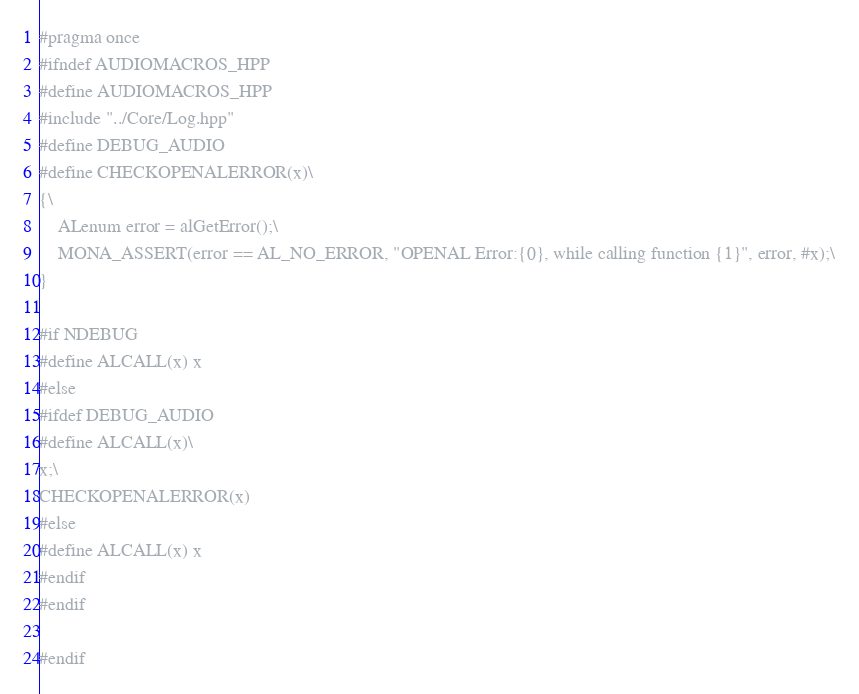Convert code to text. <code><loc_0><loc_0><loc_500><loc_500><_C++_>#pragma once
#ifndef AUDIOMACROS_HPP
#define AUDIOMACROS_HPP
#include "../Core/Log.hpp"
#define DEBUG_AUDIO
#define CHECKOPENALERROR(x)\
{\
	ALenum error = alGetError();\
	MONA_ASSERT(error == AL_NO_ERROR, "OPENAL Error:{0}, while calling function {1}", error, #x);\
}

#if NDEBUG 
#define ALCALL(x) x
#else
#ifdef DEBUG_AUDIO
#define ALCALL(x)\
x;\
CHECKOPENALERROR(x)
#else
#define ALCALL(x) x
#endif
#endif

#endif</code> 